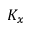<formula> <loc_0><loc_0><loc_500><loc_500>K _ { x }</formula> 